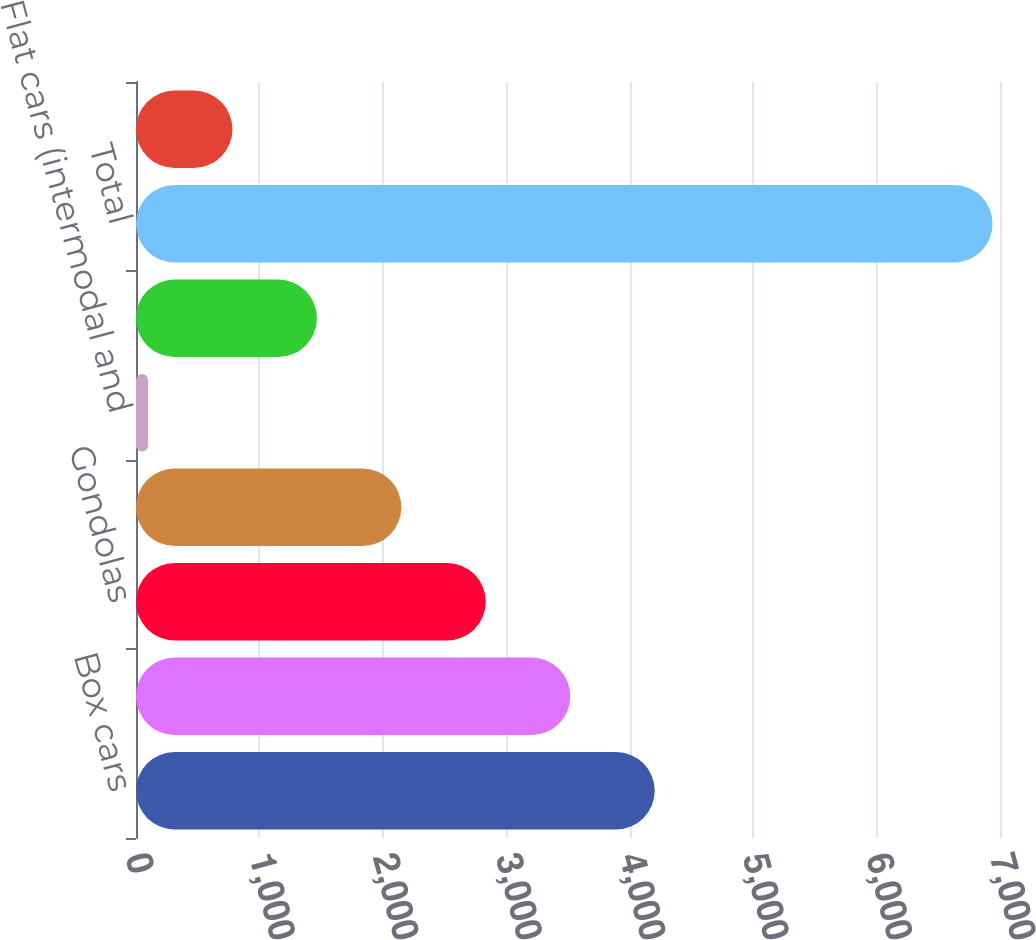Convert chart. <chart><loc_0><loc_0><loc_500><loc_500><bar_chart><fcel>Box cars<fcel>Hoppers (covered and open top)<fcel>Gondolas<fcel>Automotive<fcel>Flat cars (intermodal and<fcel>Tank cars<fcel>Total<fcel>Freight<nl><fcel>4202.8<fcel>3518.5<fcel>2834.2<fcel>2149.9<fcel>97<fcel>1465.6<fcel>6940<fcel>781.3<nl></chart> 